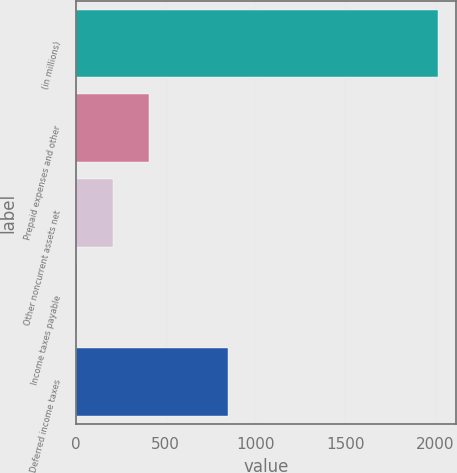Convert chart to OTSL. <chart><loc_0><loc_0><loc_500><loc_500><bar_chart><fcel>(in millions)<fcel>Prepaid expenses and other<fcel>Other noncurrent assets net<fcel>Income taxes payable<fcel>Deferred income taxes<nl><fcel>2016<fcel>405.92<fcel>204.66<fcel>3.4<fcel>848.6<nl></chart> 